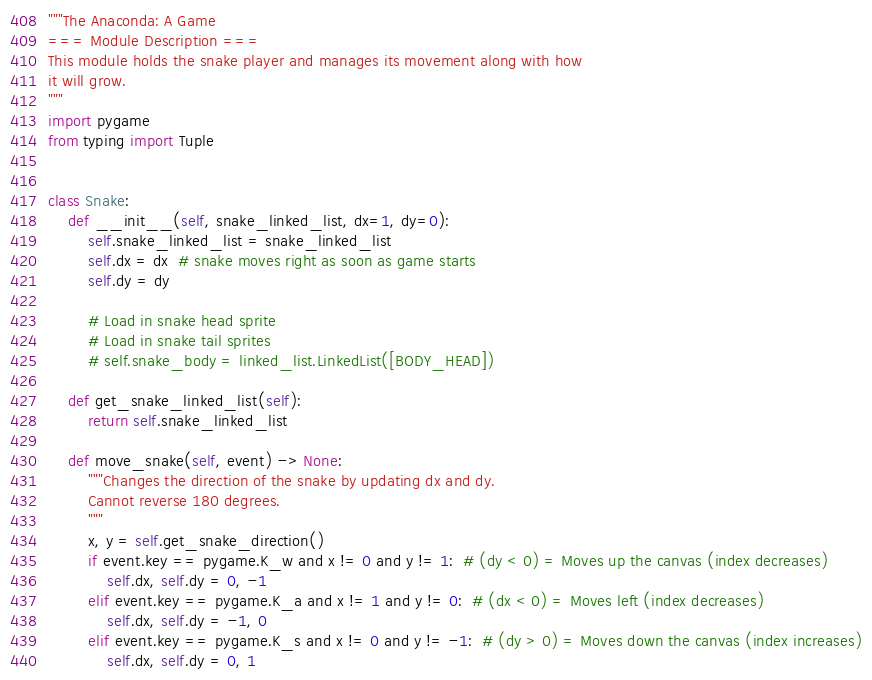Convert code to text. <code><loc_0><loc_0><loc_500><loc_500><_Python_>"""The Anaconda: A Game
=== Module Description ===
This module holds the snake player and manages its movement along with how
it will grow.
"""
import pygame
from typing import Tuple


class Snake:
    def __init__(self, snake_linked_list, dx=1, dy=0):
        self.snake_linked_list = snake_linked_list
        self.dx = dx  # snake moves right as soon as game starts
        self.dy = dy

        # Load in snake head sprite
        # Load in snake tail sprites
        # self.snake_body = linked_list.LinkedList([BODY_HEAD])

    def get_snake_linked_list(self):
        return self.snake_linked_list

    def move_snake(self, event) -> None:
        """Changes the direction of the snake by updating dx and dy.
        Cannot reverse 180 degrees.
        """
        x, y = self.get_snake_direction()
        if event.key == pygame.K_w and x != 0 and y != 1:  # (dy < 0) = Moves up the canvas (index decreases)
            self.dx, self.dy = 0, -1
        elif event.key == pygame.K_a and x != 1 and y != 0:  # (dx < 0) = Moves left (index decreases)
            self.dx, self.dy = -1, 0
        elif event.key == pygame.K_s and x != 0 and y != -1:  # (dy > 0) = Moves down the canvas (index increases)
            self.dx, self.dy = 0, 1</code> 